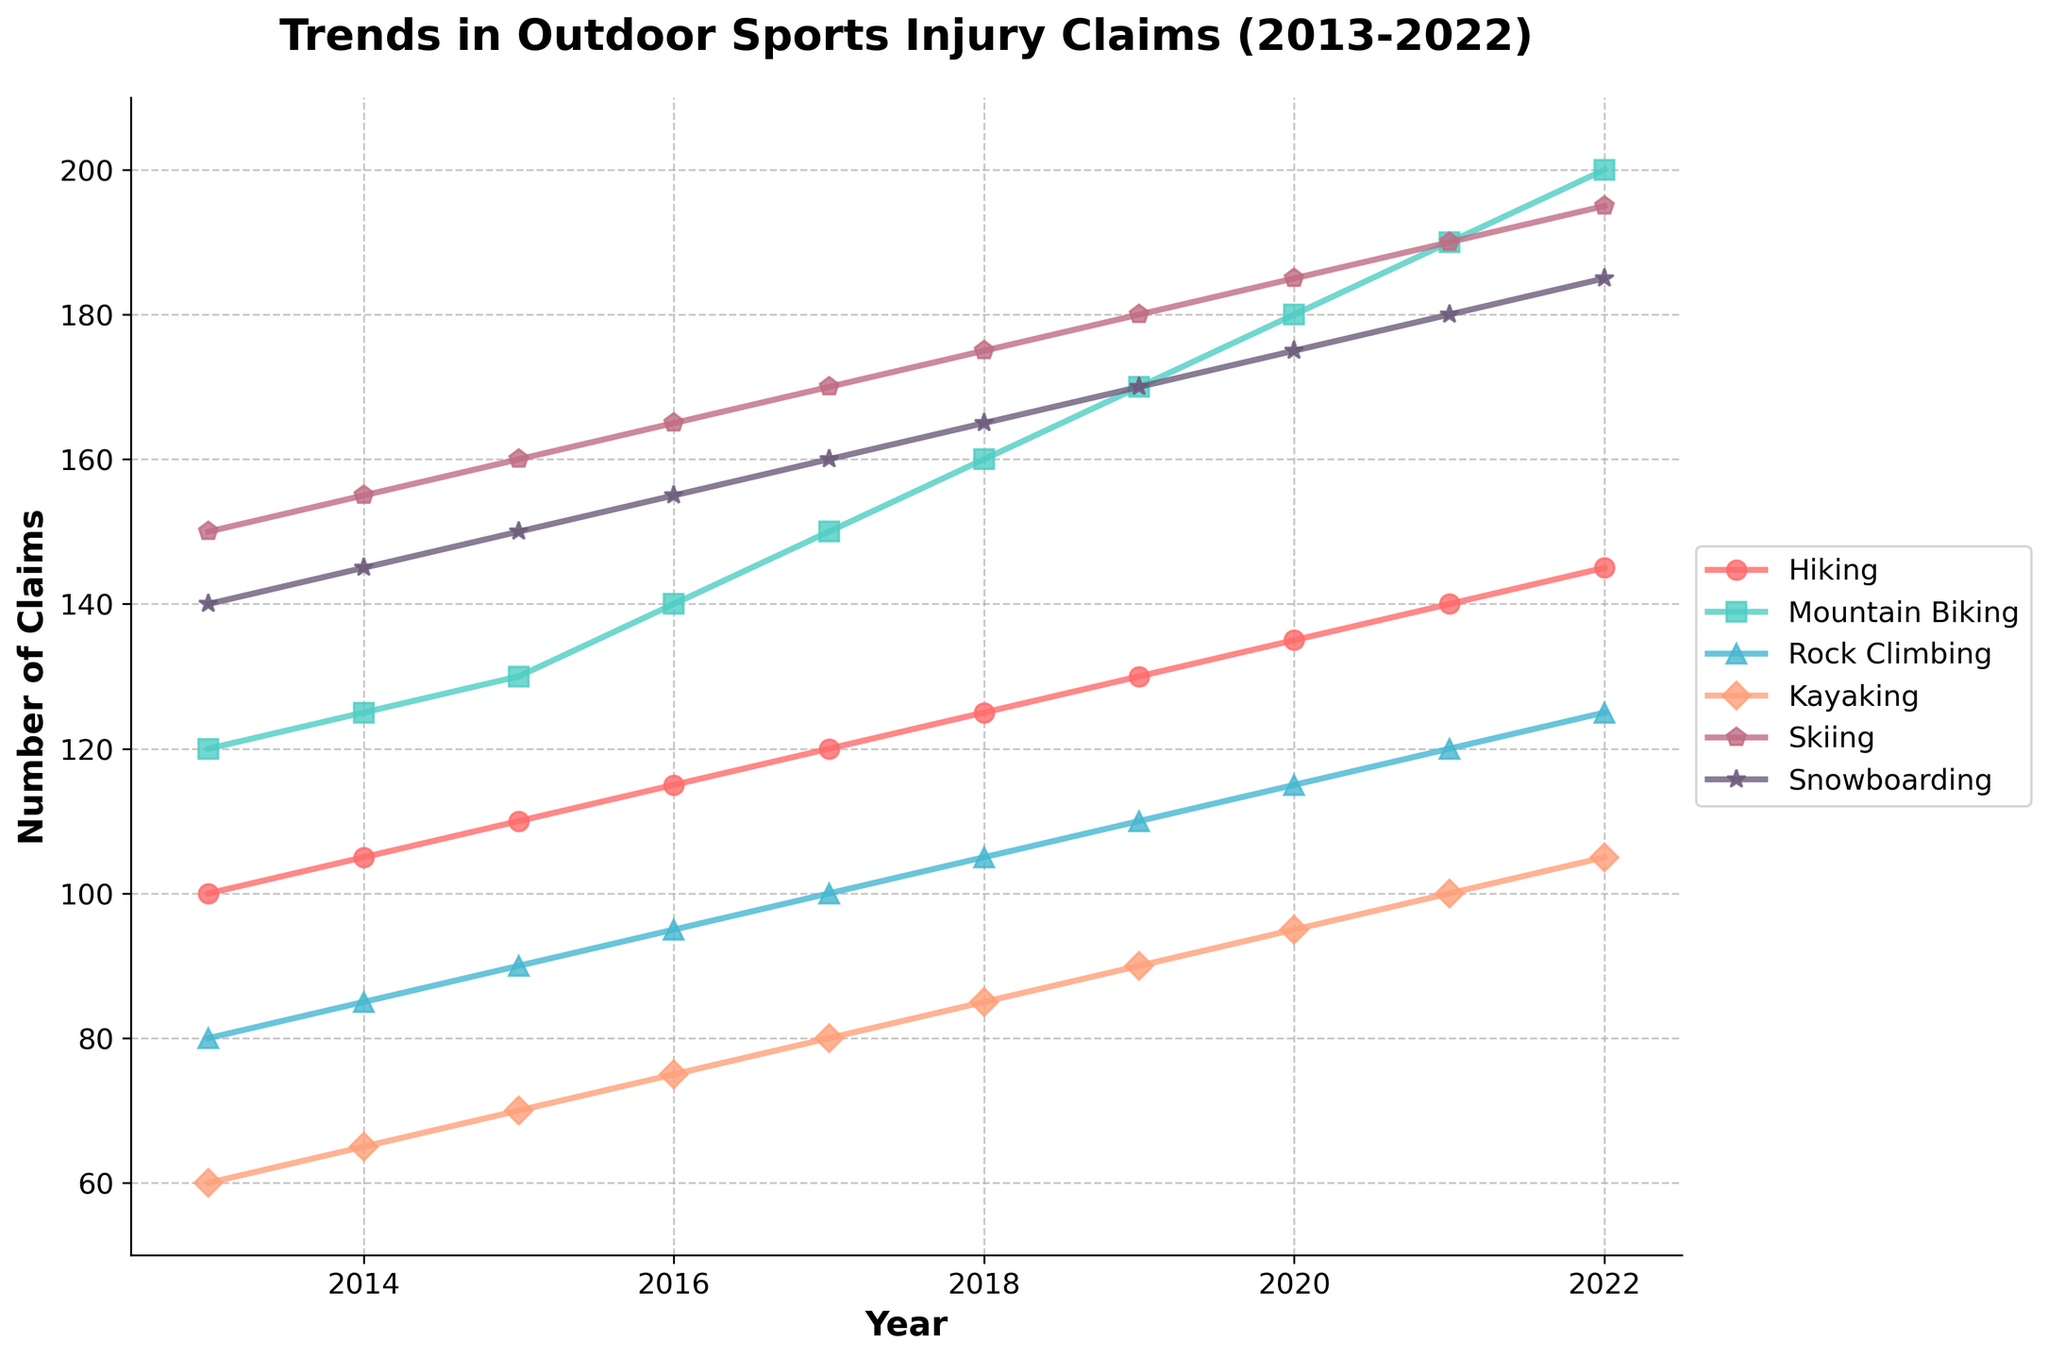What is the overall trend in the number of injury claims for Mountain Biking between 2013 and 2022? The number of injury claims for Mountain Biking increases steadily from 120 in 2013 to 200 in 2022. Each year shows a consistent rise.
Answer: Increasing trend Which outdoor sport had the highest number of injury claims in 2022? In 2022, Skiing had the highest number of injury claims at 195. This is evident as it is the tallest peak on the rightmost side of the line chart.
Answer: Skiing By how much did the total number of injury claims for Rock Climbing increase from 2013 to 2022? In 2013, the number of injury claims for Rock Climbing was 80, and it rose to 125 in 2022. The increase is calculated by subtracting the 2013 value from the 2022 value: 125 - 80 = 45.
Answer: 45 Which two activities have the closest number of injury claims in 2019, and what are their respective numbers? In 2019, Kayaking and Rock Climbing have the closest number of injury claims at 90 and 110, respectively. They are close in value, and their lines on the graph are situated near each other around that year.
Answer: Kayaking: 90, Rock Climbing: 110 Calculate the average number of injury claims for Snowboarding over the decade. The yearly injury claims for Snowboarding from 2013 to 2022 are: 140, 145, 150, 155, 160, 165, 170, 175, 180, 185. Adding these gives a total of 1625, and dividing by 10 years gives an average of 162.5.
Answer: 162.5 Compare the trend between Hiking and Kayaking. Which activity had a steadier increase in injury claims? Both Hiking and Kayaking have an increasing trend, but Hiking shows a more steady and consistent rise each year compared to Kayaking, which also increases but at a more variable rate.
Answer: Hiking What is the difference in the number of injury claims between Skiing and Snowboarding in 2020? In 2020, the number of injury claims for Skiing is 185 and for Snowboarding is 175. The difference is calculated by subtracting the Snowboarding claims from the Skiing claims: 185 - 175 = 10.
Answer: 10 Identify any activity that had the same or very close number of injury claims for any two consecutive years and state those years. Mountain Biking had very close injury claims in 2018 (160) and 2019 (170). The increase is more significant between other years compared to the shift from 2018 to 2019.
Answer: Mountain Biking (2018 and 2019) Which activity showed the steepest increase in claims from 2018 to 2019? Mountain Biking shows the steepest increase in claims from 2018 (160) to 2019 (170), with an increase of 10 claims. This is the most significant rise when compared year-on-year among the activities.
Answer: Mountain Biking 